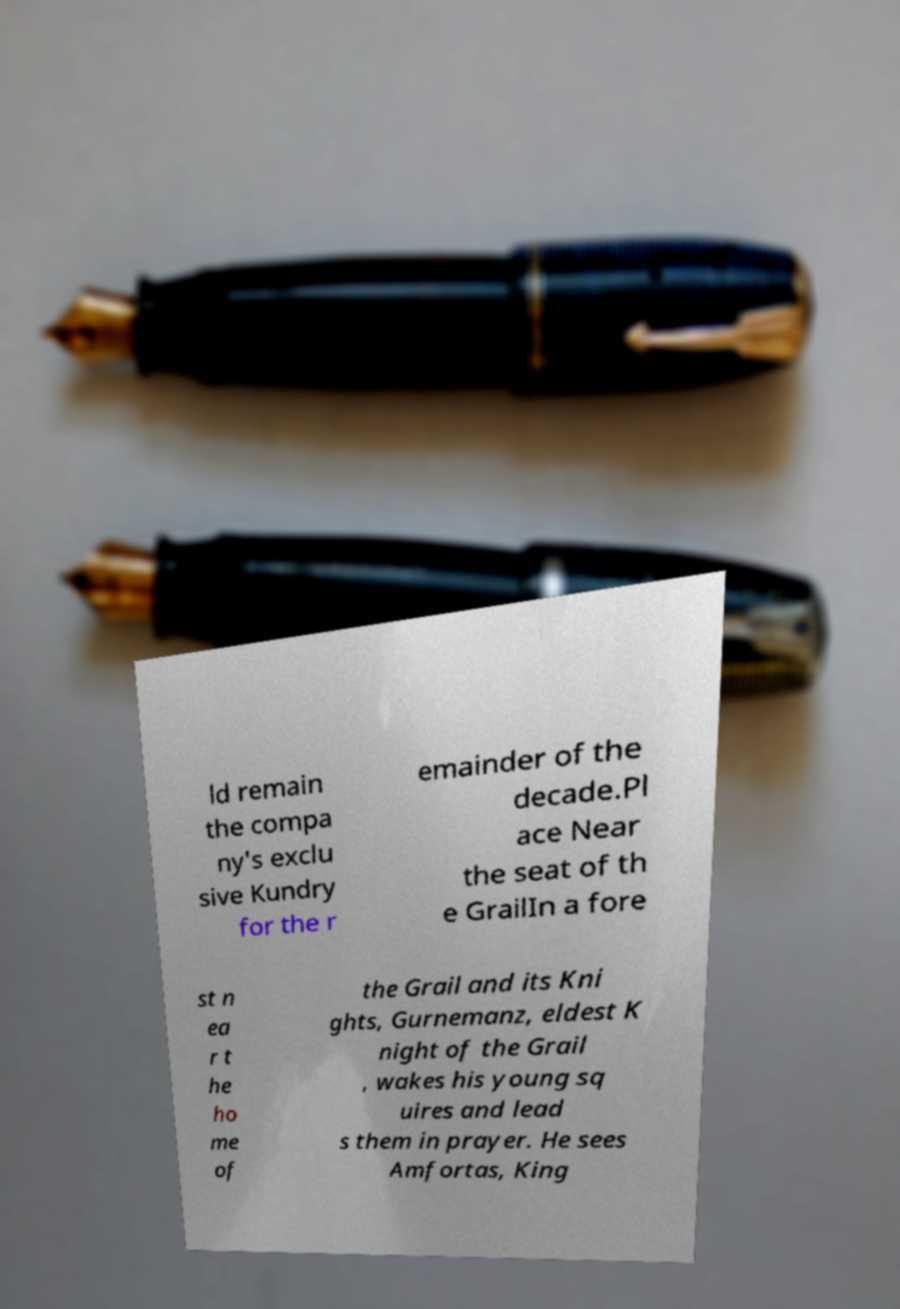For documentation purposes, I need the text within this image transcribed. Could you provide that? ld remain the compa ny's exclu sive Kundry for the r emainder of the decade.Pl ace Near the seat of th e GrailIn a fore st n ea r t he ho me of the Grail and its Kni ghts, Gurnemanz, eldest K night of the Grail , wakes his young sq uires and lead s them in prayer. He sees Amfortas, King 